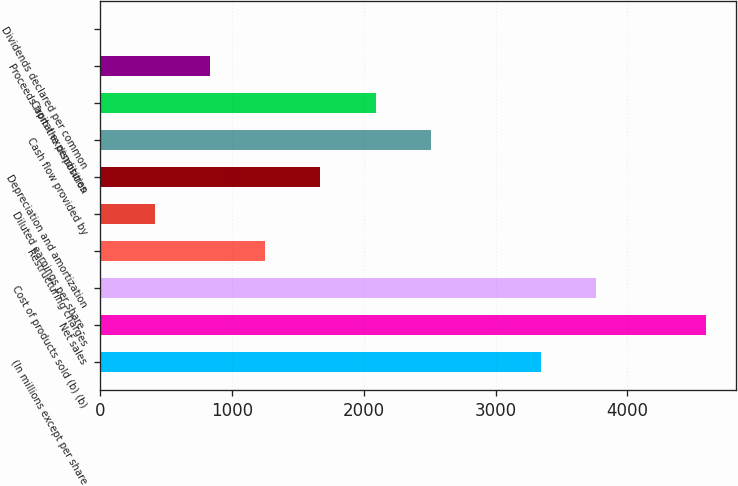Convert chart. <chart><loc_0><loc_0><loc_500><loc_500><bar_chart><fcel>(In millions except per share<fcel>Net sales<fcel>Cost of products sold (b) (b)<fcel>Restructuring charges<fcel>Diluted earnings per share -<fcel>Depreciation and amortization<fcel>Cash flow provided by<fcel>Capital expenditures<fcel>Proceeds from the disposition<fcel>Dividends declared per common<nl><fcel>3341.54<fcel>4594.46<fcel>3759.18<fcel>1253.34<fcel>418.06<fcel>1670.98<fcel>2506.26<fcel>2088.62<fcel>835.7<fcel>0.42<nl></chart> 